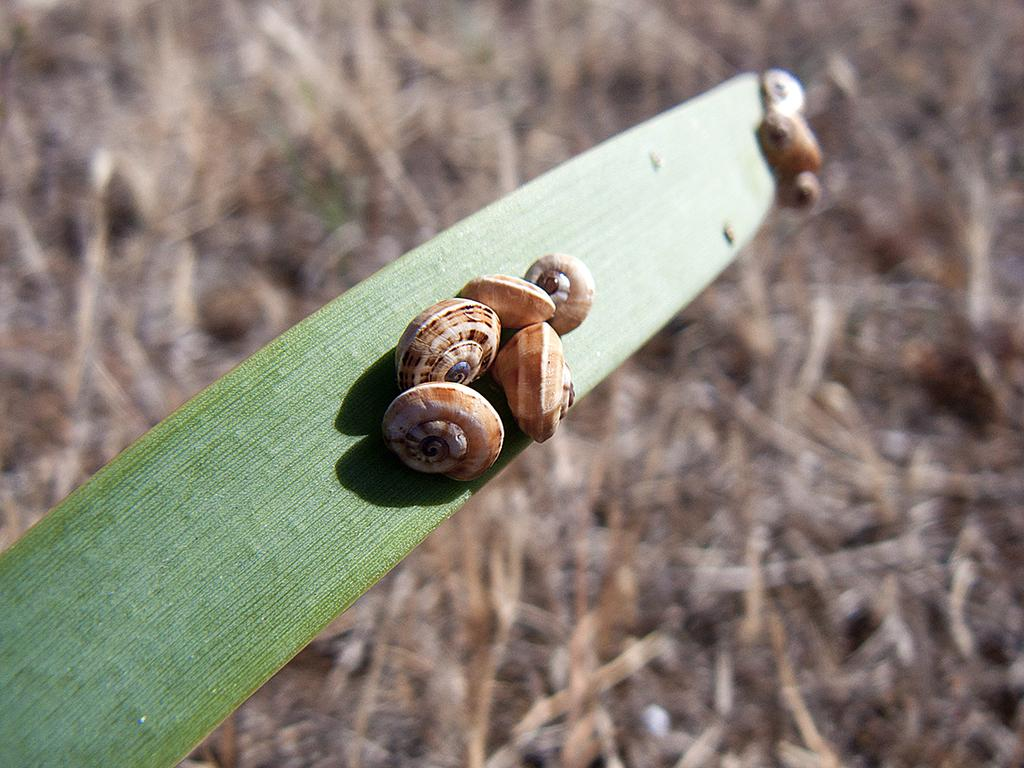What type of animals are in the image? There are pond snails in the image. Where are the pond snails located? The pond snails are on a leaf. Can you describe the background of the image? The background of the image is blurred. What type of wine is being served at the party in the image? There is no party or wine present in the image; it features pond snails on a leaf with a blurred background. 